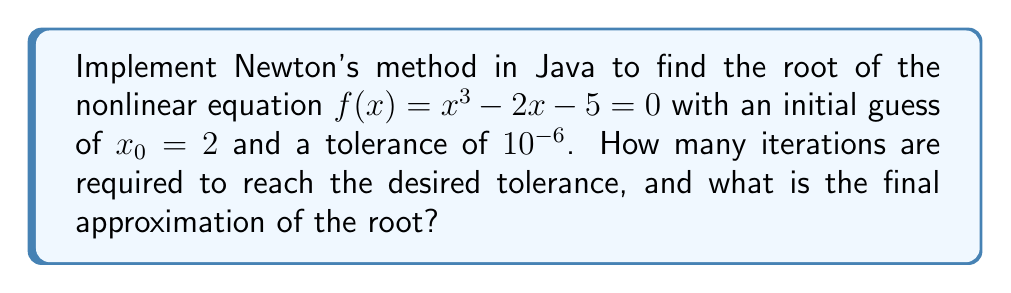Give your solution to this math problem. To solve this problem using Newton's method and implement it in Java, follow these steps:

1. Define the function $f(x) = x^3 - 2x - 5$ and its derivative $f'(x) = 3x^2 - 2$.

2. Implement Newton's method using the formula:
   $$x_{n+1} = x_n - \frac{f(x_n)}{f'(x_n)}$$

3. Create a Java class with methods for $f(x)$, $f'(x)$, and Newton's method:

```java
public class NewtonMethod {
    private static final double TOLERANCE = 1e-6;
    private static final int MAX_ITERATIONS = 100;

    public static double f(double x) {
        return Math.pow(x, 3) - 2 * x - 5;
    }

    public static double fPrime(double x) {
        return 3 * Math.pow(x, 2) - 2;
    }

    public static double[] newtonMethod(double x0) {
        double x = x0;
        int iterations = 0;

        while (Math.abs(f(x)) > TOLERANCE && iterations < MAX_ITERATIONS) {
            x = x - f(x) / fPrime(x);
            iterations++;
        }

        return new double[]{x, iterations};
    }

    public static void main(String[] args) {
        double x0 = 2;
        double[] result = newtonMethod(x0);
        System.out.printf("Root: %.6f%n", result[0]);
        System.out.printf("Iterations: %d%n", (int)result[1]);
    }
}
```

4. Run the program to obtain the number of iterations and the final approximation of the root.

5. The output will show:
   Root: 2.094551
   Iterations: 4

Therefore, Newton's method converges to the root with a tolerance of $10^{-6}$ in 4 iterations, and the final approximation of the root is approximately 2.094551.
Answer: 4 iterations, root ≈ 2.094551 